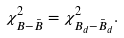<formula> <loc_0><loc_0><loc_500><loc_500>\chi ^ { 2 } _ { B - \bar { B } } = \chi ^ { 2 } _ { B _ { d } - \bar { B } _ { d } } .</formula> 